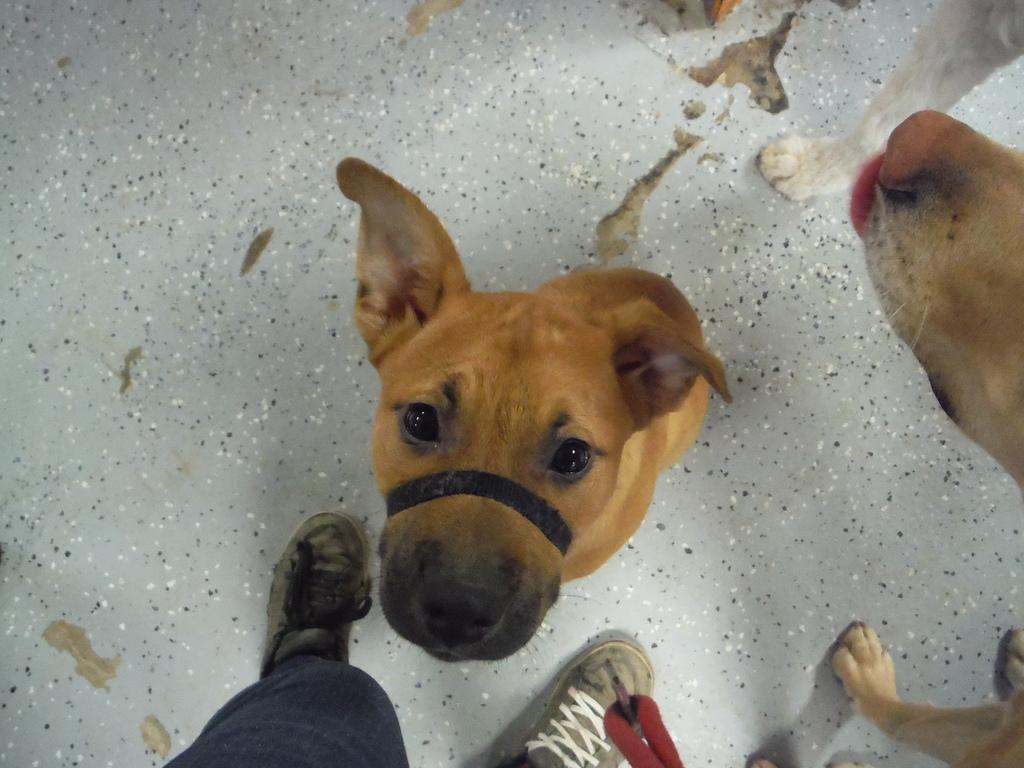What type of animals are in the image? There are dogs in the image. Where are the dogs located? The dogs are on the floor. Can you describe any other elements in the image? There are person's legs visible in the image. What color is the spot on the sofa in the image? There is no sofa or spot mentioned in the provided facts, so we cannot answer this question. 